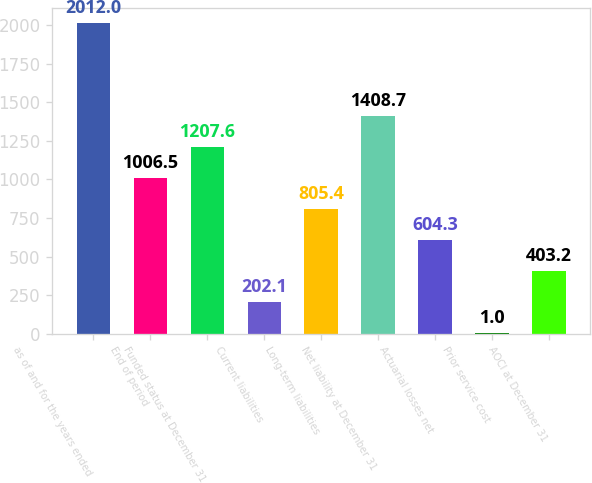Convert chart to OTSL. <chart><loc_0><loc_0><loc_500><loc_500><bar_chart><fcel>as of and for the years ended<fcel>End of period<fcel>Funded status at December 31<fcel>Current liabilities<fcel>Long-term liabilities<fcel>Net liability at December 31<fcel>Actuarial losses net<fcel>Prior service cost<fcel>AOCI at December 31<nl><fcel>2012<fcel>1006.5<fcel>1207.6<fcel>202.1<fcel>805.4<fcel>1408.7<fcel>604.3<fcel>1<fcel>403.2<nl></chart> 